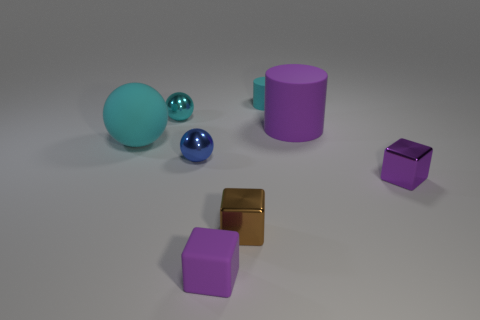What size is the other metal object that is the same shape as the brown metallic object?
Your answer should be compact. Small. There is a cylinder that is the same color as the matte block; what is its material?
Provide a succinct answer. Rubber. What number of tiny cylinders are the same color as the large ball?
Make the answer very short. 1. How many objects are tiny metal things that are in front of the tiny blue metal object or cyan rubber things?
Ensure brevity in your answer.  4. There is a sphere that is the same material as the big cylinder; what color is it?
Offer a very short reply. Cyan. Are there any rubber blocks that have the same size as the blue metallic sphere?
Your response must be concise. Yes. How many objects are either metal things that are in front of the blue metal thing or small metal objects in front of the blue metal ball?
Your answer should be very brief. 2. What shape is the cyan metal object that is the same size as the brown shiny thing?
Keep it short and to the point. Sphere. Are there any small blue metal things that have the same shape as the tiny purple matte object?
Provide a succinct answer. No. Are there fewer brown metallic things than large blue matte things?
Make the answer very short. No. 